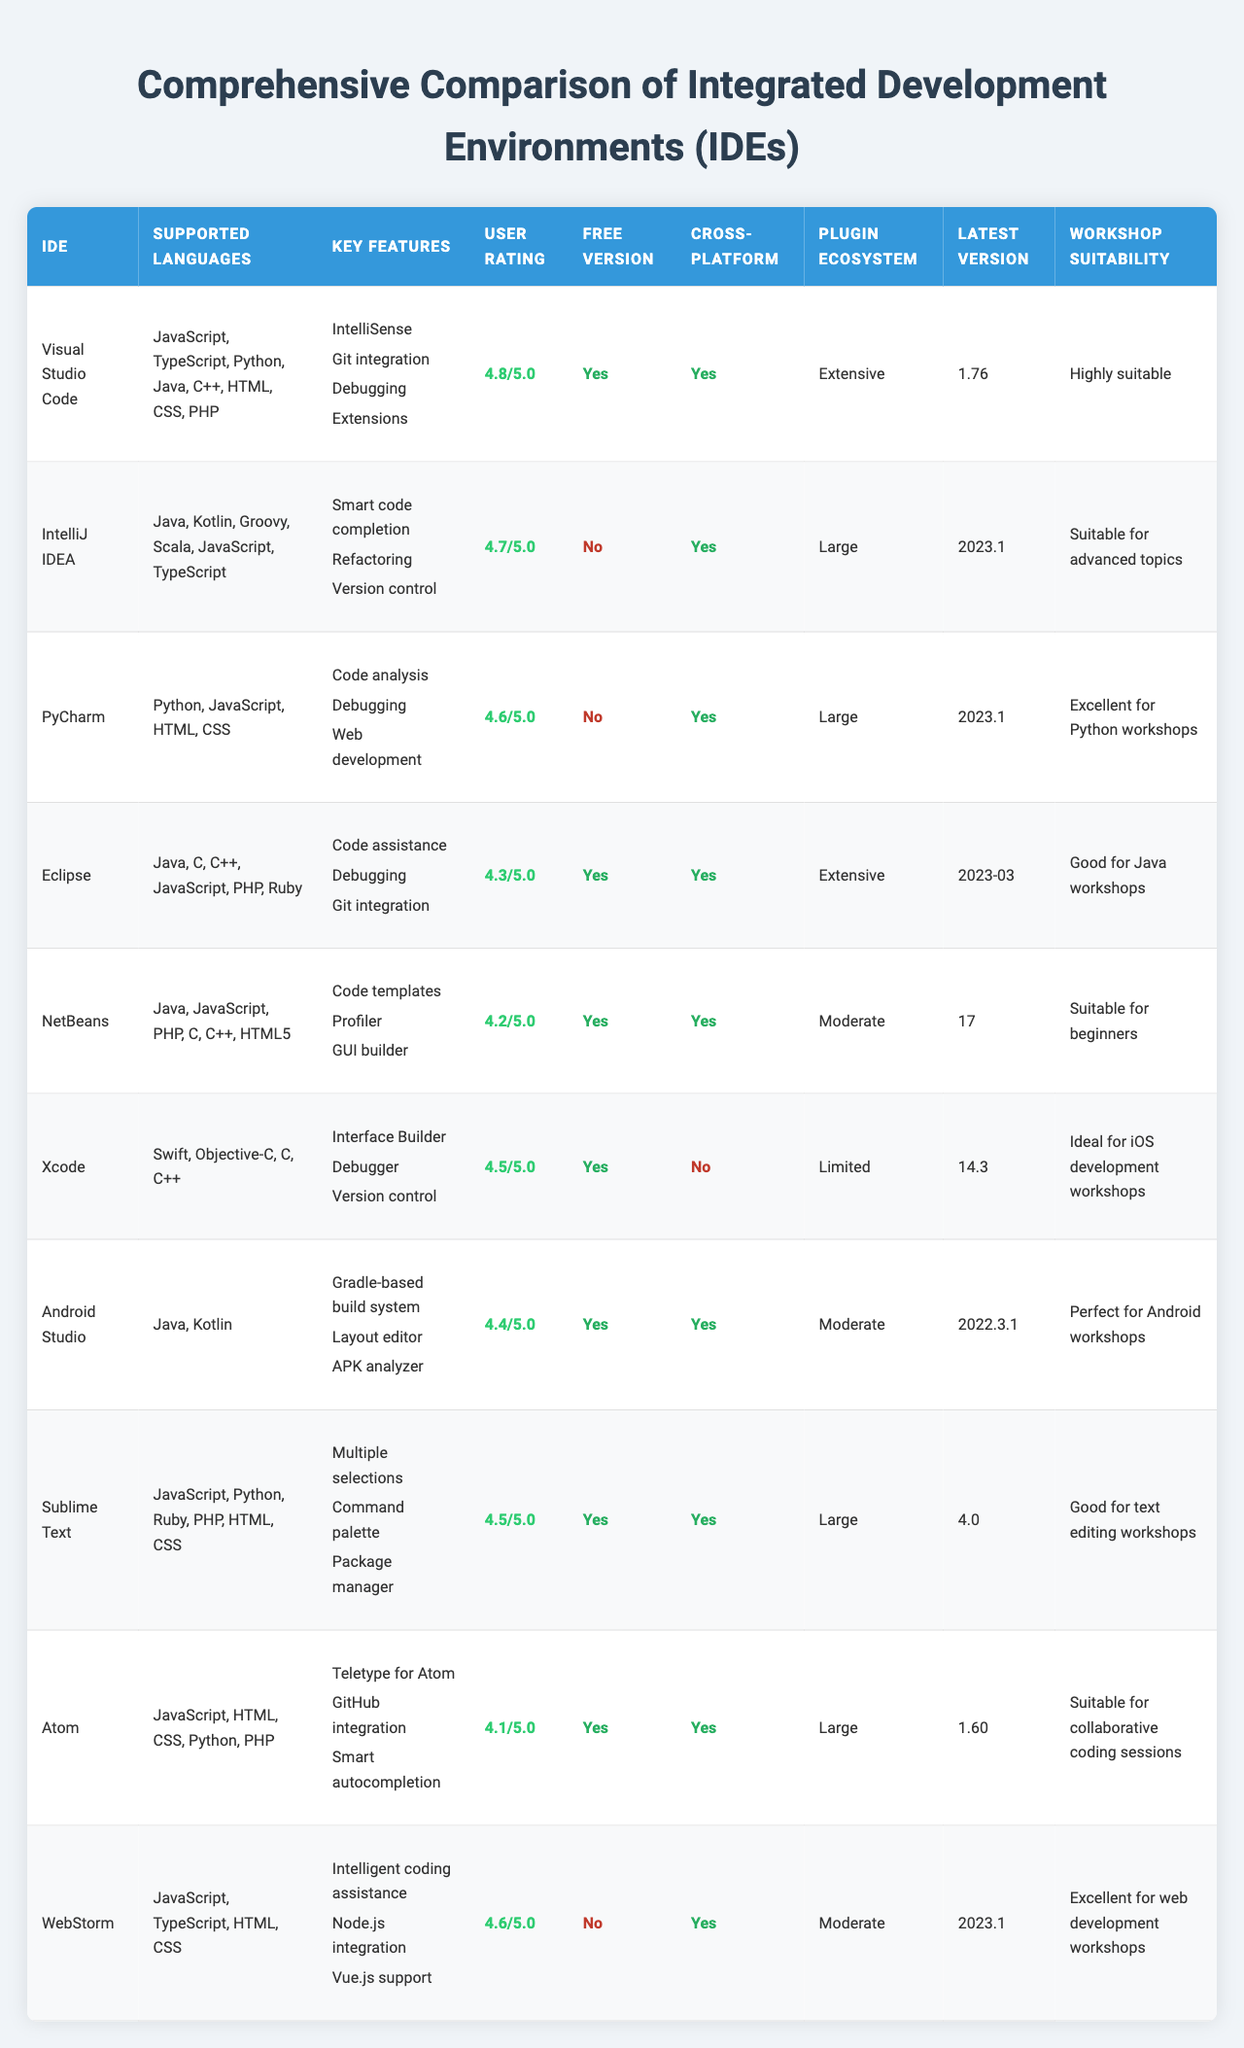What IDE has the highest user rating? The user ratings for the IDEs are listed in the table. Visual Studio Code has a rating of 4.8, which is the highest among all listed options.
Answer: Visual Studio Code Which IDE is suitable for Python workshops? Looking at the "Workshop Suitability" column, PyCharm is categorized as "Excellent for Python workshops."
Answer: PyCharm Is there a free version available for IntelliJ IDEA? Checking the "Free Version" column for IntelliJ IDEA, it shows "No," indicating that a free version is not available.
Answer: No How many IDEs support Java? By reviewing the "Supported Languages" column, the IDEs that include Java in their supported languages are IntelliJ IDEA, Eclipse, NetBeans, and Xcode, which totals four IDEs.
Answer: 4 Which IDEs are cross-platform? The "Cross-Platform" column indicates that Visual Studio Code, IntelliJ IDEA, PyCharm, Eclipse, NetBeans, Android Studio, Sublime Text, Atom, and WebStorm are marked as "Yes," totaling eight IDEs.
Answer: 8 What is the average user rating of the listed IDEs? The user ratings are: 4.8, 4.7, 4.6, 4.3, 4.2, 4.5, 4.4, 4.5, 4.1, and 4.6. Summing these gives 44.7, and dividing by the 10 IDEs provides an average user rating of 4.47.
Answer: 4.47 Among the IDEs, which one has the most extensive plugin ecosystem? From the "Plugin Ecosystem" column, both Visual Studio Code and Eclipse are described as having "Extensive" plugin ecosystems.
Answer: Visual Studio Code and Eclipse Which IDE is ideal for iOS development workshops and does it have a free version? Xcode is marked as "Ideal for iOS development workshops," and under the "Free Version" column, it states "Yes," indicating that it does have a free version.
Answer: Yes What is the latest version of WebStorm? The "Latest Version" column shows that the latest version of WebStorm is 2023.1.
Answer: 2023.1 Which IDE supports the most programming languages? By counting the supported languages listed in the "Supported Languages" column, Visual Studio Code supports seven languages, which is the highest compared to the other IDEs.
Answer: Visual Studio Code 